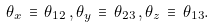<formula> <loc_0><loc_0><loc_500><loc_500>\theta _ { x } \, \equiv \, \theta _ { 1 2 } \, , \theta _ { y } \, \equiv \, \theta _ { 2 3 } \, , \theta _ { z } \, \equiv \, \theta _ { 1 3 } .</formula> 